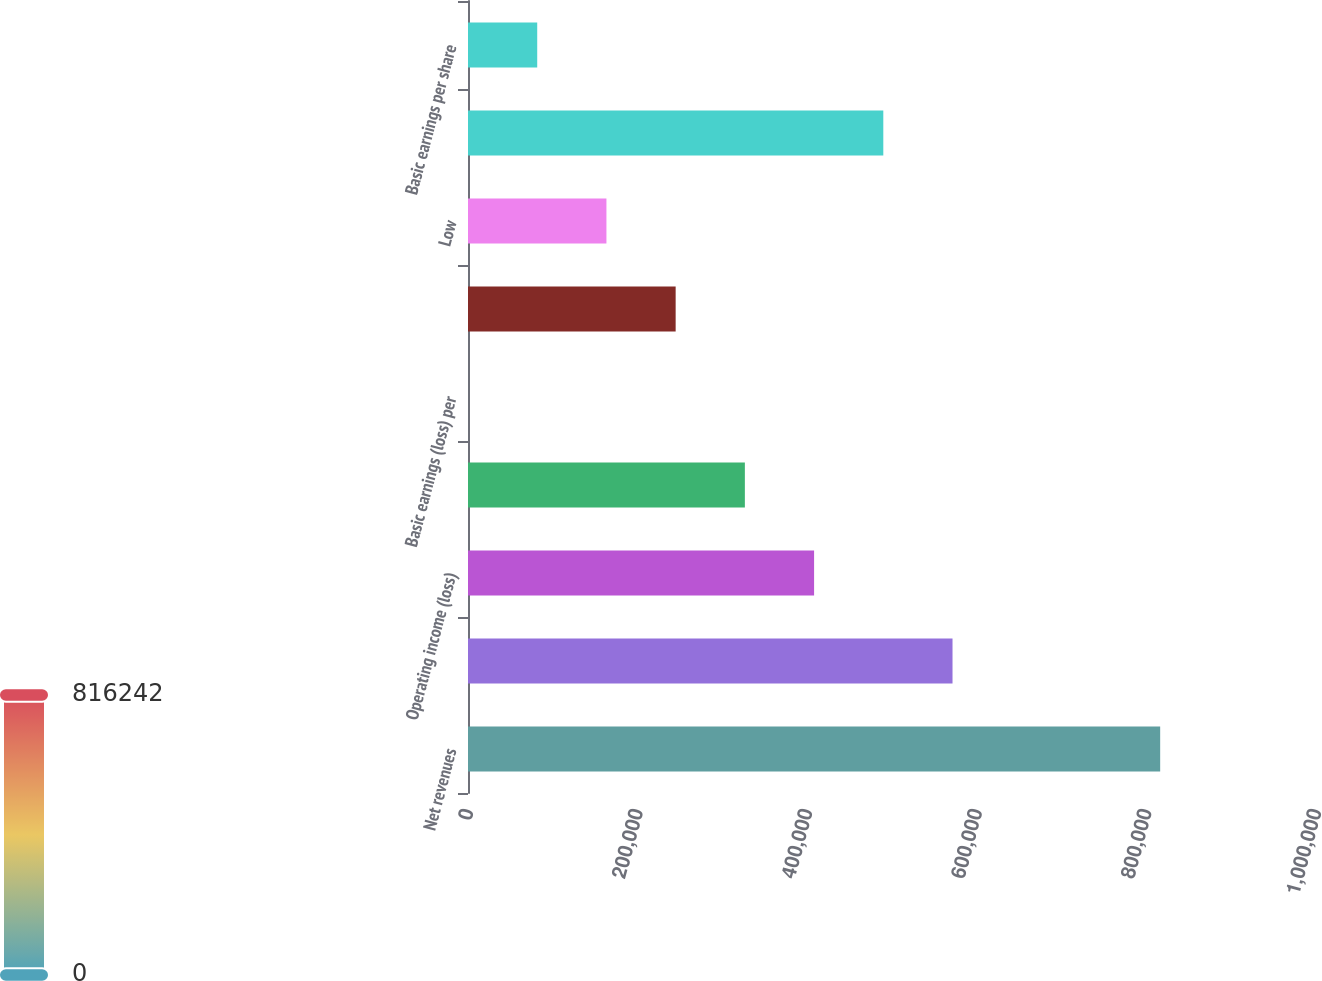Convert chart to OTSL. <chart><loc_0><loc_0><loc_500><loc_500><bar_chart><fcel>Net revenues<fcel>Cost of sales<fcel>Operating income (loss)<fcel>Net income (loss)<fcel>Basic earnings (loss) per<fcel>High<fcel>Low<fcel>Net income<fcel>Basic earnings per share<nl><fcel>816242<fcel>571369<fcel>408121<fcel>326497<fcel>0.25<fcel>244873<fcel>163249<fcel>489745<fcel>81624.4<nl></chart> 